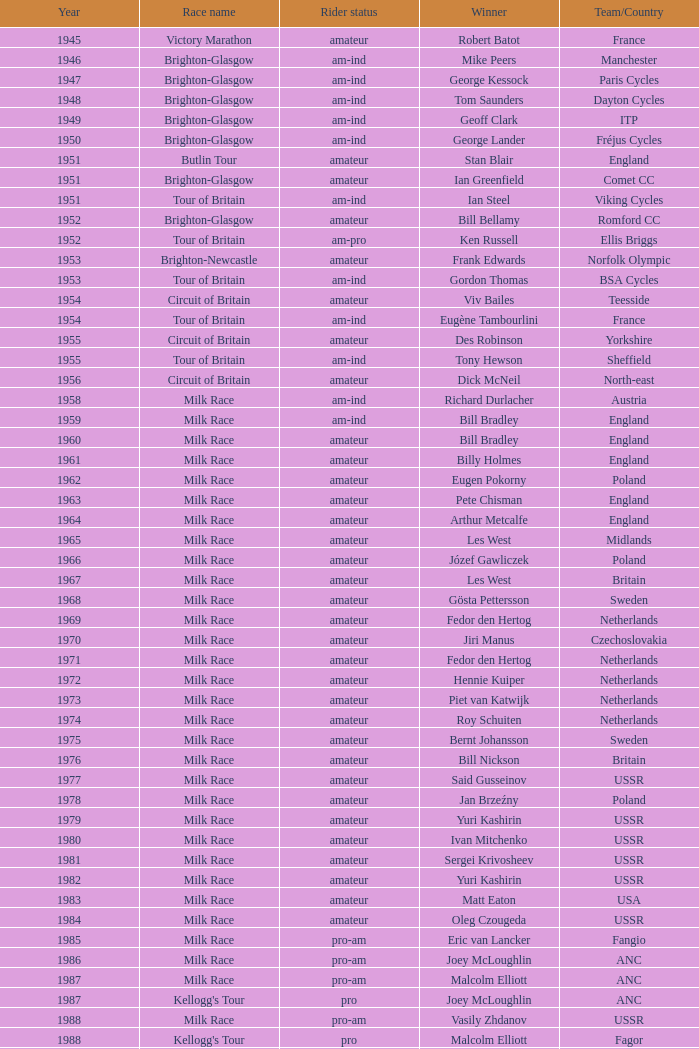In the kellogg's tour, which team played beyond 1958? ANC, Fagor, Z-Peugeot, Weinnmann-SMM, Motorola, Motorola, Motorola, Lampre. 